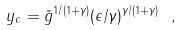<formula> <loc_0><loc_0><loc_500><loc_500>y _ { c } = \tilde { g } ^ { 1 / ( 1 + \gamma ) } ( \epsilon / \gamma ) ^ { \gamma / ( 1 + \gamma ) } \ ,</formula> 